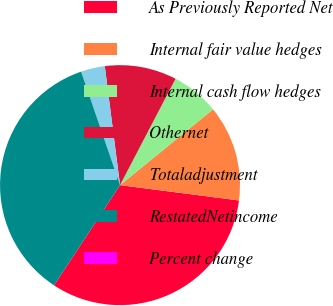Convert chart. <chart><loc_0><loc_0><loc_500><loc_500><pie_chart><fcel>As Previously Reported Net<fcel>Internal fair value hedges<fcel>Internal cash flow hedges<fcel>Othernet<fcel>Totaladjustment<fcel>RestatedNetincome<fcel>Percent change<nl><fcel>32.24%<fcel>12.92%<fcel>6.46%<fcel>9.69%<fcel>3.23%<fcel>35.47%<fcel>0.0%<nl></chart> 